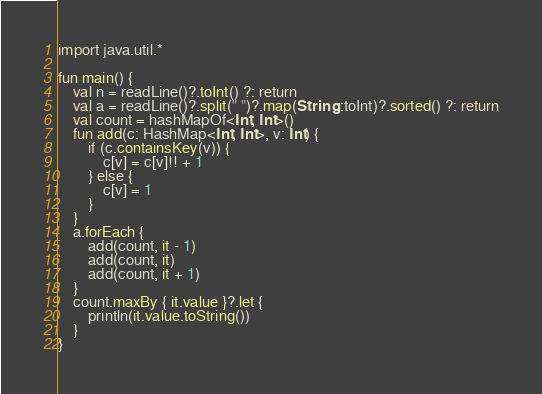<code> <loc_0><loc_0><loc_500><loc_500><_Kotlin_>import java.util.*

fun main() {
    val n = readLine()?.toInt() ?: return
    val a = readLine()?.split(" ")?.map(String::toInt)?.sorted() ?: return
    val count = hashMapOf<Int, Int>()
    fun add(c: HashMap<Int, Int>, v: Int) {
        if (c.containsKey(v)) {
            c[v] = c[v]!! + 1
        } else {
            c[v] = 1
        }
    }
    a.forEach {
        add(count, it - 1)
        add(count, it)
        add(count, it + 1)
    }
    count.maxBy { it.value }?.let {
        println(it.value.toString())
    }
}
</code> 